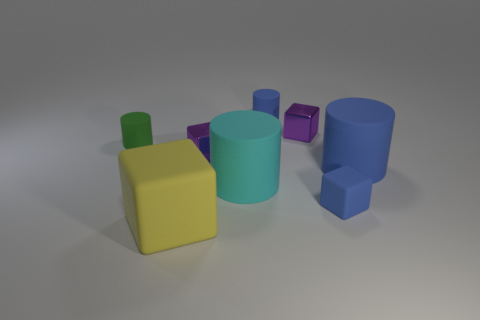Is there any pattern to the arrangement of objects? There is no immediately apparent pattern to the arrangement of the objects. They are scattered randomly, with varying distances and positions relative to one another. 